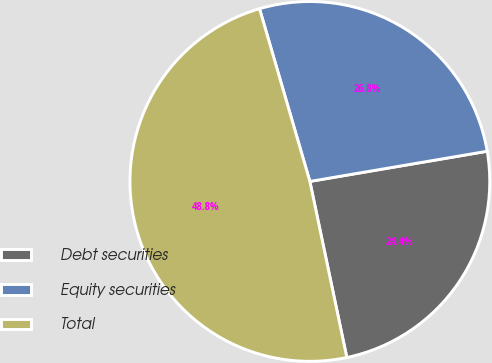<chart> <loc_0><loc_0><loc_500><loc_500><pie_chart><fcel>Debt securities<fcel>Equity securities<fcel>Total<nl><fcel>24.39%<fcel>26.83%<fcel>48.78%<nl></chart> 